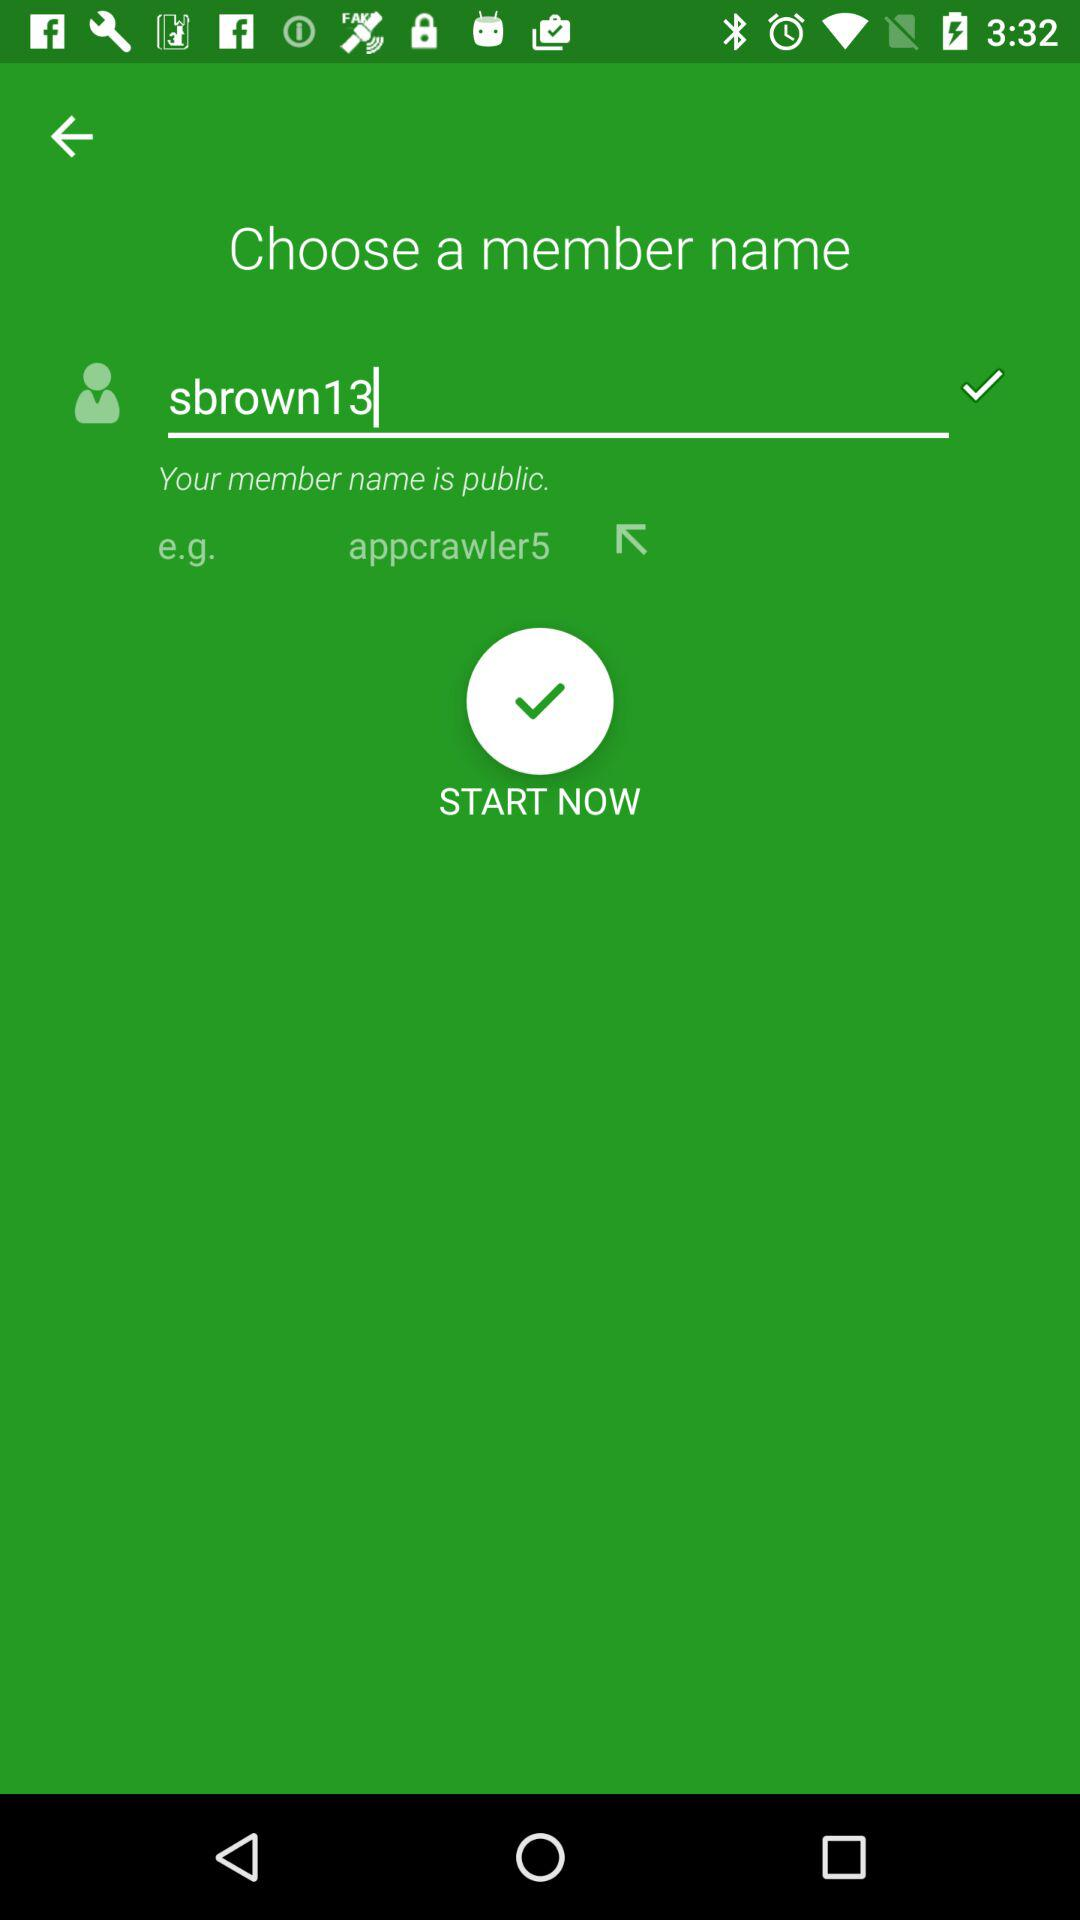What is the member name? The member name is "sbrown13". 